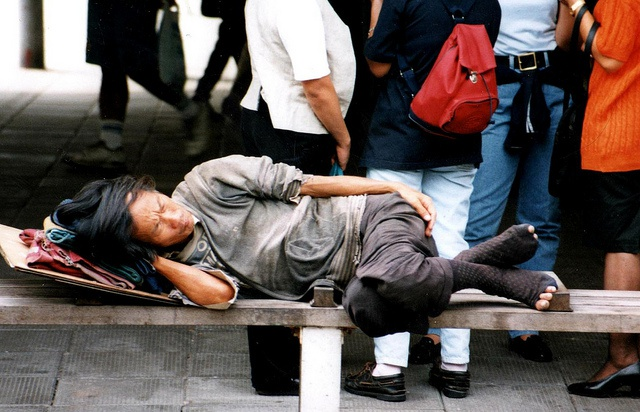Describe the objects in this image and their specific colors. I can see people in white, black, gray, darkgray, and lightgray tones, people in white, black, brown, and lavender tones, bench in white, gray, black, and darkgray tones, people in white, black, navy, blue, and teal tones, and people in white, black, salmon, and darkgray tones in this image. 